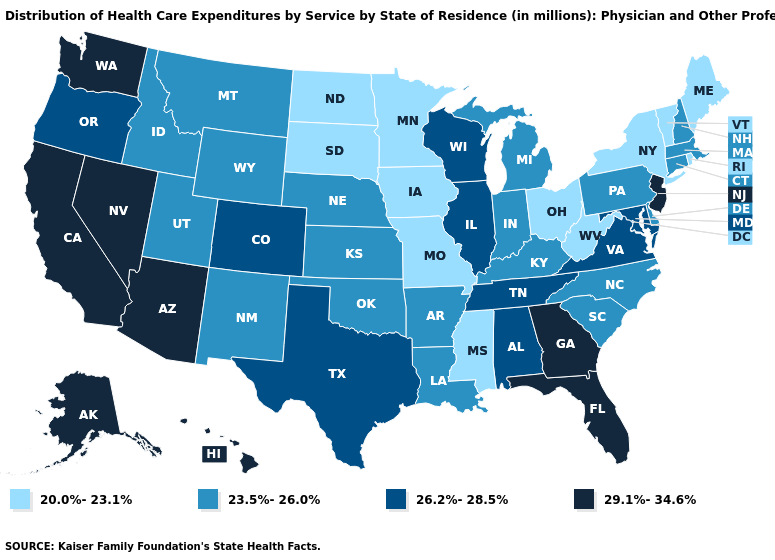What is the value of Mississippi?
Concise answer only. 20.0%-23.1%. Name the states that have a value in the range 20.0%-23.1%?
Short answer required. Iowa, Maine, Minnesota, Mississippi, Missouri, New York, North Dakota, Ohio, Rhode Island, South Dakota, Vermont, West Virginia. Does California have the highest value in the West?
Short answer required. Yes. What is the value of Idaho?
Give a very brief answer. 23.5%-26.0%. Which states hav the highest value in the South?
Concise answer only. Florida, Georgia. What is the value of North Dakota?
Write a very short answer. 20.0%-23.1%. Name the states that have a value in the range 26.2%-28.5%?
Quick response, please. Alabama, Colorado, Illinois, Maryland, Oregon, Tennessee, Texas, Virginia, Wisconsin. What is the value of West Virginia?
Quick response, please. 20.0%-23.1%. Does Nebraska have a lower value than California?
Write a very short answer. Yes. Does North Carolina have a higher value than New York?
Give a very brief answer. Yes. Which states have the highest value in the USA?
Be succinct. Alaska, Arizona, California, Florida, Georgia, Hawaii, Nevada, New Jersey, Washington. Among the states that border Michigan , does Ohio have the lowest value?
Give a very brief answer. Yes. Which states have the lowest value in the West?
Write a very short answer. Idaho, Montana, New Mexico, Utah, Wyoming. What is the lowest value in the USA?
Be succinct. 20.0%-23.1%. Name the states that have a value in the range 26.2%-28.5%?
Short answer required. Alabama, Colorado, Illinois, Maryland, Oregon, Tennessee, Texas, Virginia, Wisconsin. 